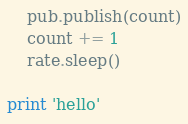<code> <loc_0><loc_0><loc_500><loc_500><_Python_>    pub.publish(count)
    count += 1
    rate.sleep()

print 'hello'
</code> 